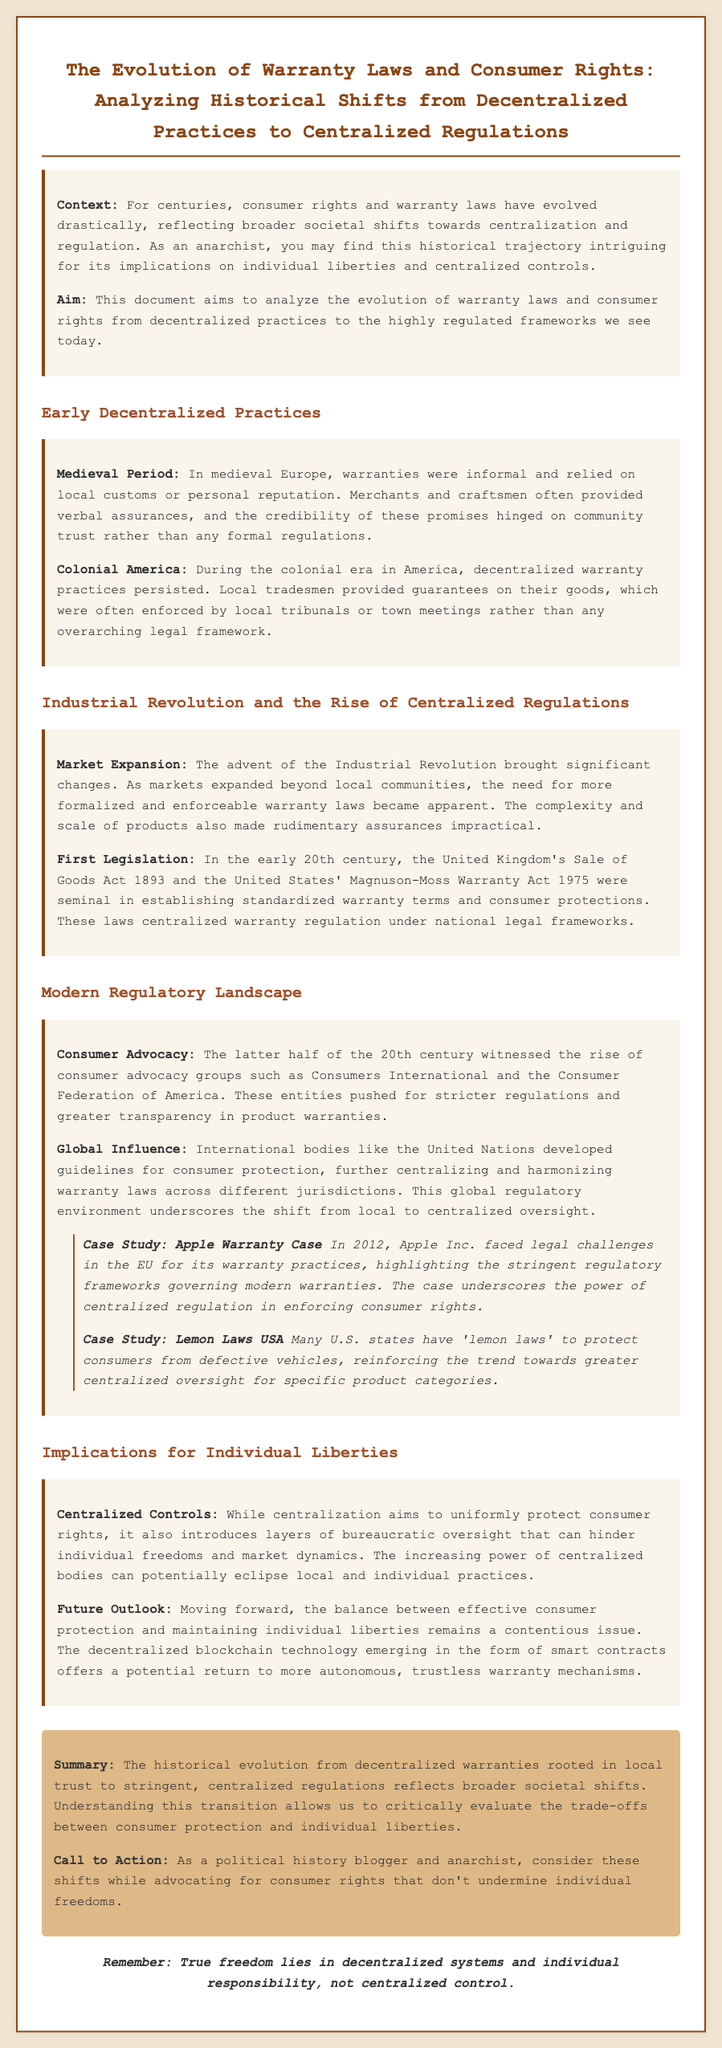what was the focus of the early decentralized warranty practices? Early decentralized warranty practices focused on local customs and personal reputation, relying on community trust.
Answer: community trust which act established standardized warranty terms in the UK? The Sale of Goods Act 1893 established standardized warranty terms in the UK.
Answer: Sale of Goods Act 1893 what year was the Magnuson-Moss Warranty Act enacted? The Magnuson-Moss Warranty Act was enacted in 1975.
Answer: 1975 which organizations pushed for stricter warranty regulations in the 20th century? Consumer advocacy groups such as Consumers International and the Consumer Federation of America.
Answer: Consumers International and Consumer Federation of America what did the Apple Warranty Case in 2012 highlight? The Apple Warranty Case in 2012 highlighted the stringent regulatory frameworks governing modern warranties.
Answer: stringent regulatory frameworks how has the shift to centralized regulations affected individual liberties? The shift to centralized regulations has introduced bureaucratic oversight that can hinder individual freedoms.
Answer: hinder individual freedoms what emerging technology offers a potential return to decentralized warranty practices? Decentralized blockchain technology offers a potential return to more autonomous warranty mechanisms.
Answer: blockchain technology what is the main implication of centralized controls according to the document? Centralized controls can eclipse local and individual practices and potentially hinder market dynamics.
Answer: eclipse local practices 